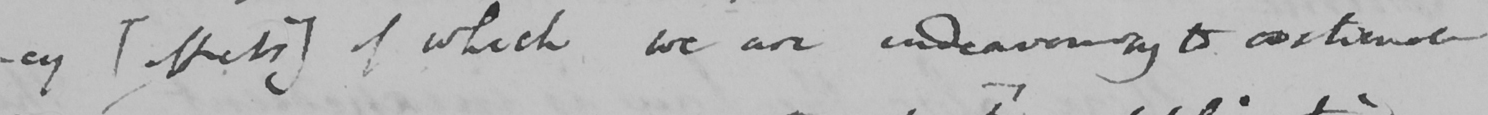Transcribe the text shown in this historical manuscript line. -cy  [ effects ]  of which we are endeavouring to continual 